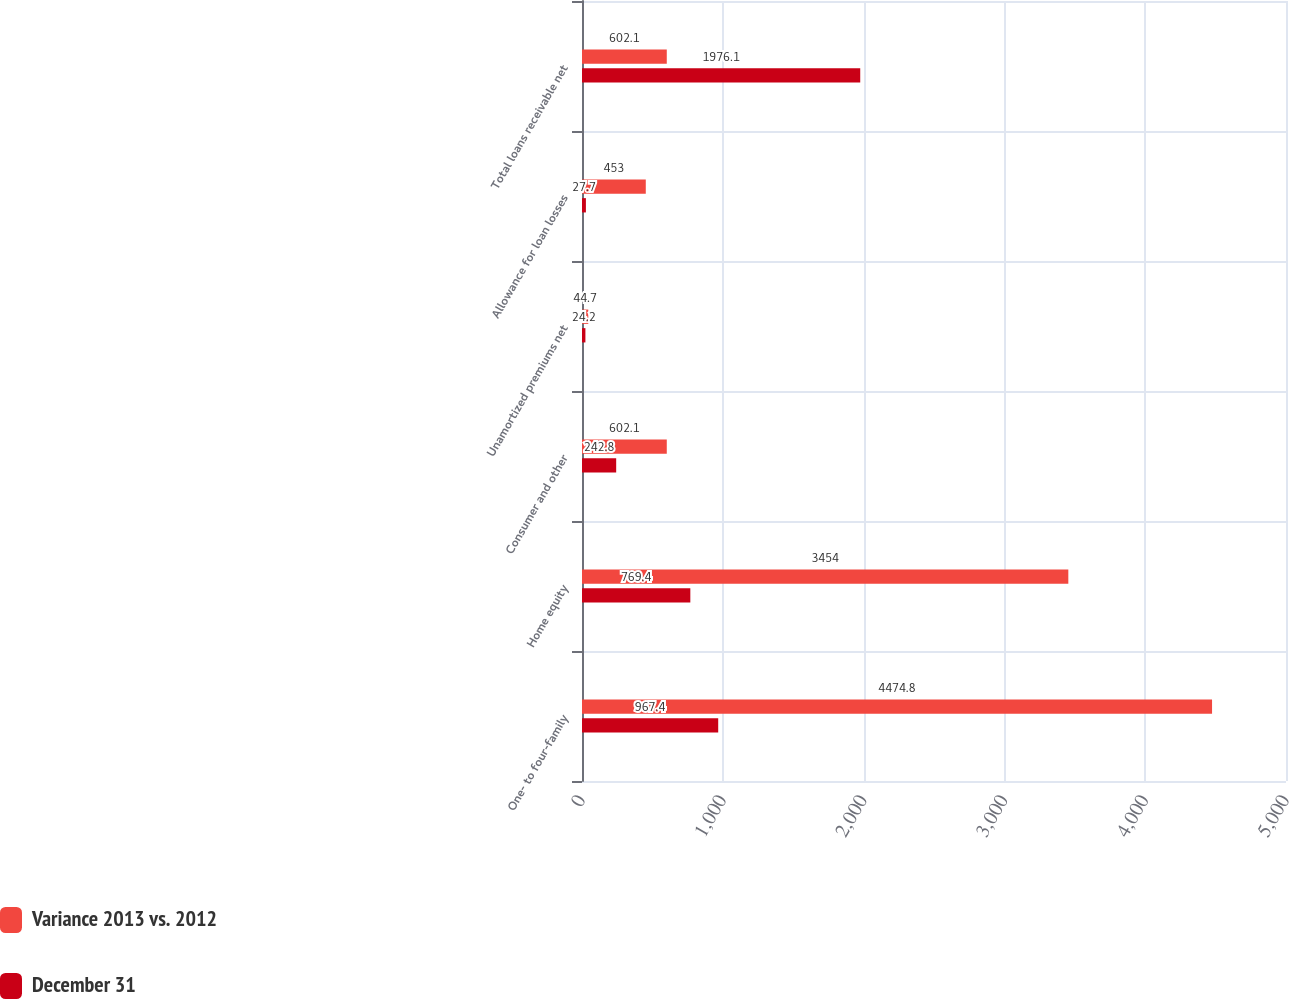Convert chart to OTSL. <chart><loc_0><loc_0><loc_500><loc_500><stacked_bar_chart><ecel><fcel>One- to four-family<fcel>Home equity<fcel>Consumer and other<fcel>Unamortized premiums net<fcel>Allowance for loan losses<fcel>Total loans receivable net<nl><fcel>Variance 2013 vs. 2012<fcel>4474.8<fcel>3454<fcel>602.1<fcel>44.7<fcel>453<fcel>602.1<nl><fcel>December 31<fcel>967.4<fcel>769.4<fcel>242.8<fcel>24.2<fcel>27.7<fcel>1976.1<nl></chart> 